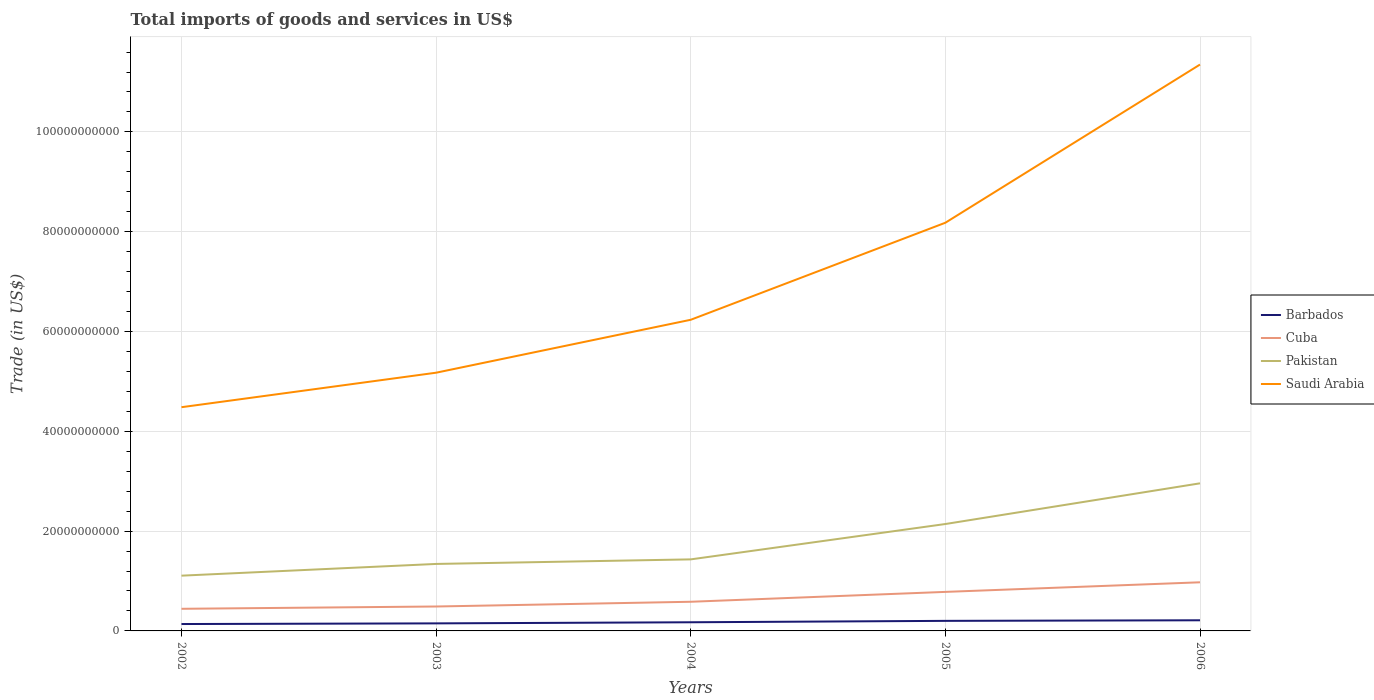How many different coloured lines are there?
Make the answer very short. 4. Is the number of lines equal to the number of legend labels?
Offer a very short reply. Yes. Across all years, what is the maximum total imports of goods and services in Saudi Arabia?
Offer a very short reply. 4.48e+1. What is the total total imports of goods and services in Saudi Arabia in the graph?
Make the answer very short. -1.94e+1. What is the difference between the highest and the second highest total imports of goods and services in Pakistan?
Make the answer very short. 1.85e+1. What is the difference between the highest and the lowest total imports of goods and services in Saudi Arabia?
Keep it short and to the point. 2. Is the total imports of goods and services in Cuba strictly greater than the total imports of goods and services in Barbados over the years?
Make the answer very short. No. How many lines are there?
Provide a succinct answer. 4. Are the values on the major ticks of Y-axis written in scientific E-notation?
Provide a short and direct response. No. Where does the legend appear in the graph?
Keep it short and to the point. Center right. How are the legend labels stacked?
Provide a short and direct response. Vertical. What is the title of the graph?
Ensure brevity in your answer.  Total imports of goods and services in US$. Does "Equatorial Guinea" appear as one of the legend labels in the graph?
Give a very brief answer. No. What is the label or title of the X-axis?
Provide a short and direct response. Years. What is the label or title of the Y-axis?
Keep it short and to the point. Trade (in US$). What is the Trade (in US$) in Barbados in 2002?
Offer a very short reply. 1.38e+09. What is the Trade (in US$) in Cuba in 2002?
Offer a terse response. 4.43e+09. What is the Trade (in US$) in Pakistan in 2002?
Offer a very short reply. 1.11e+1. What is the Trade (in US$) in Saudi Arabia in 2002?
Your answer should be very brief. 4.48e+1. What is the Trade (in US$) in Barbados in 2003?
Offer a terse response. 1.51e+09. What is the Trade (in US$) in Cuba in 2003?
Ensure brevity in your answer.  4.90e+09. What is the Trade (in US$) in Pakistan in 2003?
Provide a succinct answer. 1.34e+1. What is the Trade (in US$) in Saudi Arabia in 2003?
Provide a succinct answer. 5.17e+1. What is the Trade (in US$) of Barbados in 2004?
Make the answer very short. 1.73e+09. What is the Trade (in US$) in Cuba in 2004?
Offer a terse response. 5.84e+09. What is the Trade (in US$) in Pakistan in 2004?
Offer a very short reply. 1.43e+1. What is the Trade (in US$) of Saudi Arabia in 2004?
Your answer should be very brief. 6.24e+1. What is the Trade (in US$) of Barbados in 2005?
Keep it short and to the point. 2.02e+09. What is the Trade (in US$) in Cuba in 2005?
Offer a terse response. 7.82e+09. What is the Trade (in US$) in Pakistan in 2005?
Give a very brief answer. 2.14e+1. What is the Trade (in US$) in Saudi Arabia in 2005?
Offer a terse response. 8.18e+1. What is the Trade (in US$) of Barbados in 2006?
Give a very brief answer. 2.13e+09. What is the Trade (in US$) of Cuba in 2006?
Provide a short and direct response. 9.74e+09. What is the Trade (in US$) in Pakistan in 2006?
Keep it short and to the point. 2.96e+1. What is the Trade (in US$) of Saudi Arabia in 2006?
Provide a short and direct response. 1.13e+11. Across all years, what is the maximum Trade (in US$) of Barbados?
Provide a succinct answer. 2.13e+09. Across all years, what is the maximum Trade (in US$) of Cuba?
Your answer should be very brief. 9.74e+09. Across all years, what is the maximum Trade (in US$) of Pakistan?
Provide a short and direct response. 2.96e+1. Across all years, what is the maximum Trade (in US$) in Saudi Arabia?
Offer a terse response. 1.13e+11. Across all years, what is the minimum Trade (in US$) of Barbados?
Your answer should be compact. 1.38e+09. Across all years, what is the minimum Trade (in US$) in Cuba?
Provide a succinct answer. 4.43e+09. Across all years, what is the minimum Trade (in US$) of Pakistan?
Offer a terse response. 1.11e+1. Across all years, what is the minimum Trade (in US$) in Saudi Arabia?
Ensure brevity in your answer.  4.48e+1. What is the total Trade (in US$) of Barbados in the graph?
Keep it short and to the point. 8.78e+09. What is the total Trade (in US$) in Cuba in the graph?
Make the answer very short. 3.27e+1. What is the total Trade (in US$) in Pakistan in the graph?
Offer a very short reply. 8.98e+1. What is the total Trade (in US$) of Saudi Arabia in the graph?
Ensure brevity in your answer.  3.54e+11. What is the difference between the Trade (in US$) in Barbados in 2002 and that in 2003?
Your response must be concise. -1.31e+08. What is the difference between the Trade (in US$) of Cuba in 2002 and that in 2003?
Ensure brevity in your answer.  -4.60e+08. What is the difference between the Trade (in US$) in Pakistan in 2002 and that in 2003?
Your response must be concise. -2.35e+09. What is the difference between the Trade (in US$) in Saudi Arabia in 2002 and that in 2003?
Your answer should be very brief. -6.91e+09. What is the difference between the Trade (in US$) of Barbados in 2002 and that in 2004?
Ensure brevity in your answer.  -3.52e+08. What is the difference between the Trade (in US$) in Cuba in 2002 and that in 2004?
Make the answer very short. -1.41e+09. What is the difference between the Trade (in US$) of Pakistan in 2002 and that in 2004?
Provide a succinct answer. -3.26e+09. What is the difference between the Trade (in US$) of Saudi Arabia in 2002 and that in 2004?
Give a very brief answer. -1.75e+1. What is the difference between the Trade (in US$) of Barbados in 2002 and that in 2005?
Keep it short and to the point. -6.35e+08. What is the difference between the Trade (in US$) of Cuba in 2002 and that in 2005?
Give a very brief answer. -3.39e+09. What is the difference between the Trade (in US$) in Pakistan in 2002 and that in 2005?
Offer a very short reply. -1.03e+1. What is the difference between the Trade (in US$) of Saudi Arabia in 2002 and that in 2005?
Offer a terse response. -3.70e+1. What is the difference between the Trade (in US$) in Barbados in 2002 and that in 2006?
Offer a very short reply. -7.50e+08. What is the difference between the Trade (in US$) in Cuba in 2002 and that in 2006?
Provide a short and direct response. -5.31e+09. What is the difference between the Trade (in US$) in Pakistan in 2002 and that in 2006?
Provide a succinct answer. -1.85e+1. What is the difference between the Trade (in US$) of Saudi Arabia in 2002 and that in 2006?
Your answer should be very brief. -6.87e+1. What is the difference between the Trade (in US$) of Barbados in 2003 and that in 2004?
Provide a succinct answer. -2.22e+08. What is the difference between the Trade (in US$) of Cuba in 2003 and that in 2004?
Keep it short and to the point. -9.46e+08. What is the difference between the Trade (in US$) of Pakistan in 2003 and that in 2004?
Keep it short and to the point. -9.14e+08. What is the difference between the Trade (in US$) of Saudi Arabia in 2003 and that in 2004?
Your response must be concise. -1.06e+1. What is the difference between the Trade (in US$) in Barbados in 2003 and that in 2005?
Your answer should be very brief. -5.04e+08. What is the difference between the Trade (in US$) in Cuba in 2003 and that in 2005?
Provide a succinct answer. -2.93e+09. What is the difference between the Trade (in US$) in Pakistan in 2003 and that in 2005?
Make the answer very short. -8.00e+09. What is the difference between the Trade (in US$) of Saudi Arabia in 2003 and that in 2005?
Give a very brief answer. -3.01e+1. What is the difference between the Trade (in US$) in Barbados in 2003 and that in 2006?
Provide a succinct answer. -6.19e+08. What is the difference between the Trade (in US$) in Cuba in 2003 and that in 2006?
Ensure brevity in your answer.  -4.85e+09. What is the difference between the Trade (in US$) in Pakistan in 2003 and that in 2006?
Give a very brief answer. -1.62e+1. What is the difference between the Trade (in US$) in Saudi Arabia in 2003 and that in 2006?
Make the answer very short. -6.18e+1. What is the difference between the Trade (in US$) in Barbados in 2004 and that in 2005?
Offer a very short reply. -2.82e+08. What is the difference between the Trade (in US$) in Cuba in 2004 and that in 2005?
Your answer should be very brief. -1.98e+09. What is the difference between the Trade (in US$) in Pakistan in 2004 and that in 2005?
Offer a terse response. -7.09e+09. What is the difference between the Trade (in US$) in Saudi Arabia in 2004 and that in 2005?
Offer a terse response. -1.94e+1. What is the difference between the Trade (in US$) of Barbados in 2004 and that in 2006?
Your answer should be very brief. -3.98e+08. What is the difference between the Trade (in US$) of Cuba in 2004 and that in 2006?
Keep it short and to the point. -3.90e+09. What is the difference between the Trade (in US$) of Pakistan in 2004 and that in 2006?
Keep it short and to the point. -1.52e+1. What is the difference between the Trade (in US$) of Saudi Arabia in 2004 and that in 2006?
Provide a succinct answer. -5.11e+1. What is the difference between the Trade (in US$) of Barbados in 2005 and that in 2006?
Your response must be concise. -1.15e+08. What is the difference between the Trade (in US$) of Cuba in 2005 and that in 2006?
Ensure brevity in your answer.  -1.92e+09. What is the difference between the Trade (in US$) of Pakistan in 2005 and that in 2006?
Keep it short and to the point. -8.15e+09. What is the difference between the Trade (in US$) in Saudi Arabia in 2005 and that in 2006?
Provide a succinct answer. -3.17e+1. What is the difference between the Trade (in US$) in Barbados in 2002 and the Trade (in US$) in Cuba in 2003?
Provide a succinct answer. -3.51e+09. What is the difference between the Trade (in US$) of Barbados in 2002 and the Trade (in US$) of Pakistan in 2003?
Provide a short and direct response. -1.20e+1. What is the difference between the Trade (in US$) in Barbados in 2002 and the Trade (in US$) in Saudi Arabia in 2003?
Ensure brevity in your answer.  -5.04e+1. What is the difference between the Trade (in US$) in Cuba in 2002 and the Trade (in US$) in Pakistan in 2003?
Your answer should be compact. -8.99e+09. What is the difference between the Trade (in US$) in Cuba in 2002 and the Trade (in US$) in Saudi Arabia in 2003?
Ensure brevity in your answer.  -4.73e+1. What is the difference between the Trade (in US$) in Pakistan in 2002 and the Trade (in US$) in Saudi Arabia in 2003?
Keep it short and to the point. -4.07e+1. What is the difference between the Trade (in US$) in Barbados in 2002 and the Trade (in US$) in Cuba in 2004?
Offer a terse response. -4.46e+09. What is the difference between the Trade (in US$) of Barbados in 2002 and the Trade (in US$) of Pakistan in 2004?
Provide a short and direct response. -1.30e+1. What is the difference between the Trade (in US$) of Barbados in 2002 and the Trade (in US$) of Saudi Arabia in 2004?
Your answer should be compact. -6.10e+1. What is the difference between the Trade (in US$) in Cuba in 2002 and the Trade (in US$) in Pakistan in 2004?
Offer a very short reply. -9.90e+09. What is the difference between the Trade (in US$) of Cuba in 2002 and the Trade (in US$) of Saudi Arabia in 2004?
Ensure brevity in your answer.  -5.79e+1. What is the difference between the Trade (in US$) of Pakistan in 2002 and the Trade (in US$) of Saudi Arabia in 2004?
Your answer should be very brief. -5.13e+1. What is the difference between the Trade (in US$) in Barbados in 2002 and the Trade (in US$) in Cuba in 2005?
Offer a very short reply. -6.44e+09. What is the difference between the Trade (in US$) of Barbados in 2002 and the Trade (in US$) of Pakistan in 2005?
Your response must be concise. -2.00e+1. What is the difference between the Trade (in US$) in Barbados in 2002 and the Trade (in US$) in Saudi Arabia in 2005?
Keep it short and to the point. -8.04e+1. What is the difference between the Trade (in US$) of Cuba in 2002 and the Trade (in US$) of Pakistan in 2005?
Your response must be concise. -1.70e+1. What is the difference between the Trade (in US$) in Cuba in 2002 and the Trade (in US$) in Saudi Arabia in 2005?
Provide a short and direct response. -7.74e+1. What is the difference between the Trade (in US$) in Pakistan in 2002 and the Trade (in US$) in Saudi Arabia in 2005?
Give a very brief answer. -7.07e+1. What is the difference between the Trade (in US$) in Barbados in 2002 and the Trade (in US$) in Cuba in 2006?
Provide a short and direct response. -8.36e+09. What is the difference between the Trade (in US$) in Barbados in 2002 and the Trade (in US$) in Pakistan in 2006?
Your answer should be compact. -2.82e+1. What is the difference between the Trade (in US$) in Barbados in 2002 and the Trade (in US$) in Saudi Arabia in 2006?
Provide a short and direct response. -1.12e+11. What is the difference between the Trade (in US$) in Cuba in 2002 and the Trade (in US$) in Pakistan in 2006?
Provide a short and direct response. -2.51e+1. What is the difference between the Trade (in US$) of Cuba in 2002 and the Trade (in US$) of Saudi Arabia in 2006?
Offer a very short reply. -1.09e+11. What is the difference between the Trade (in US$) of Pakistan in 2002 and the Trade (in US$) of Saudi Arabia in 2006?
Provide a short and direct response. -1.02e+11. What is the difference between the Trade (in US$) of Barbados in 2003 and the Trade (in US$) of Cuba in 2004?
Make the answer very short. -4.33e+09. What is the difference between the Trade (in US$) of Barbados in 2003 and the Trade (in US$) of Pakistan in 2004?
Offer a terse response. -1.28e+1. What is the difference between the Trade (in US$) in Barbados in 2003 and the Trade (in US$) in Saudi Arabia in 2004?
Your answer should be very brief. -6.08e+1. What is the difference between the Trade (in US$) in Cuba in 2003 and the Trade (in US$) in Pakistan in 2004?
Provide a succinct answer. -9.44e+09. What is the difference between the Trade (in US$) in Cuba in 2003 and the Trade (in US$) in Saudi Arabia in 2004?
Make the answer very short. -5.75e+1. What is the difference between the Trade (in US$) of Pakistan in 2003 and the Trade (in US$) of Saudi Arabia in 2004?
Your response must be concise. -4.89e+1. What is the difference between the Trade (in US$) in Barbados in 2003 and the Trade (in US$) in Cuba in 2005?
Ensure brevity in your answer.  -6.31e+09. What is the difference between the Trade (in US$) in Barbados in 2003 and the Trade (in US$) in Pakistan in 2005?
Your answer should be compact. -1.99e+1. What is the difference between the Trade (in US$) of Barbados in 2003 and the Trade (in US$) of Saudi Arabia in 2005?
Offer a very short reply. -8.03e+1. What is the difference between the Trade (in US$) of Cuba in 2003 and the Trade (in US$) of Pakistan in 2005?
Give a very brief answer. -1.65e+1. What is the difference between the Trade (in US$) in Cuba in 2003 and the Trade (in US$) in Saudi Arabia in 2005?
Ensure brevity in your answer.  -7.69e+1. What is the difference between the Trade (in US$) in Pakistan in 2003 and the Trade (in US$) in Saudi Arabia in 2005?
Make the answer very short. -6.84e+1. What is the difference between the Trade (in US$) in Barbados in 2003 and the Trade (in US$) in Cuba in 2006?
Your response must be concise. -8.23e+09. What is the difference between the Trade (in US$) of Barbados in 2003 and the Trade (in US$) of Pakistan in 2006?
Provide a short and direct response. -2.81e+1. What is the difference between the Trade (in US$) in Barbados in 2003 and the Trade (in US$) in Saudi Arabia in 2006?
Your response must be concise. -1.12e+11. What is the difference between the Trade (in US$) in Cuba in 2003 and the Trade (in US$) in Pakistan in 2006?
Keep it short and to the point. -2.47e+1. What is the difference between the Trade (in US$) of Cuba in 2003 and the Trade (in US$) of Saudi Arabia in 2006?
Your answer should be very brief. -1.09e+11. What is the difference between the Trade (in US$) of Pakistan in 2003 and the Trade (in US$) of Saudi Arabia in 2006?
Make the answer very short. -1.00e+11. What is the difference between the Trade (in US$) of Barbados in 2004 and the Trade (in US$) of Cuba in 2005?
Ensure brevity in your answer.  -6.09e+09. What is the difference between the Trade (in US$) in Barbados in 2004 and the Trade (in US$) in Pakistan in 2005?
Give a very brief answer. -1.97e+1. What is the difference between the Trade (in US$) in Barbados in 2004 and the Trade (in US$) in Saudi Arabia in 2005?
Make the answer very short. -8.01e+1. What is the difference between the Trade (in US$) of Cuba in 2004 and the Trade (in US$) of Pakistan in 2005?
Ensure brevity in your answer.  -1.56e+1. What is the difference between the Trade (in US$) of Cuba in 2004 and the Trade (in US$) of Saudi Arabia in 2005?
Provide a succinct answer. -7.60e+1. What is the difference between the Trade (in US$) of Pakistan in 2004 and the Trade (in US$) of Saudi Arabia in 2005?
Offer a terse response. -6.75e+1. What is the difference between the Trade (in US$) in Barbados in 2004 and the Trade (in US$) in Cuba in 2006?
Your answer should be very brief. -8.01e+09. What is the difference between the Trade (in US$) of Barbados in 2004 and the Trade (in US$) of Pakistan in 2006?
Your response must be concise. -2.78e+1. What is the difference between the Trade (in US$) in Barbados in 2004 and the Trade (in US$) in Saudi Arabia in 2006?
Your answer should be compact. -1.12e+11. What is the difference between the Trade (in US$) of Cuba in 2004 and the Trade (in US$) of Pakistan in 2006?
Keep it short and to the point. -2.37e+1. What is the difference between the Trade (in US$) of Cuba in 2004 and the Trade (in US$) of Saudi Arabia in 2006?
Make the answer very short. -1.08e+11. What is the difference between the Trade (in US$) in Pakistan in 2004 and the Trade (in US$) in Saudi Arabia in 2006?
Your response must be concise. -9.92e+1. What is the difference between the Trade (in US$) of Barbados in 2005 and the Trade (in US$) of Cuba in 2006?
Ensure brevity in your answer.  -7.73e+09. What is the difference between the Trade (in US$) in Barbados in 2005 and the Trade (in US$) in Pakistan in 2006?
Give a very brief answer. -2.76e+1. What is the difference between the Trade (in US$) of Barbados in 2005 and the Trade (in US$) of Saudi Arabia in 2006?
Your answer should be very brief. -1.11e+11. What is the difference between the Trade (in US$) in Cuba in 2005 and the Trade (in US$) in Pakistan in 2006?
Your response must be concise. -2.18e+1. What is the difference between the Trade (in US$) in Cuba in 2005 and the Trade (in US$) in Saudi Arabia in 2006?
Offer a terse response. -1.06e+11. What is the difference between the Trade (in US$) in Pakistan in 2005 and the Trade (in US$) in Saudi Arabia in 2006?
Provide a short and direct response. -9.21e+1. What is the average Trade (in US$) in Barbados per year?
Offer a very short reply. 1.76e+09. What is the average Trade (in US$) in Cuba per year?
Your answer should be very brief. 6.55e+09. What is the average Trade (in US$) of Pakistan per year?
Offer a very short reply. 1.80e+1. What is the average Trade (in US$) in Saudi Arabia per year?
Give a very brief answer. 7.08e+1. In the year 2002, what is the difference between the Trade (in US$) in Barbados and Trade (in US$) in Cuba?
Offer a terse response. -3.05e+09. In the year 2002, what is the difference between the Trade (in US$) in Barbados and Trade (in US$) in Pakistan?
Your answer should be compact. -9.69e+09. In the year 2002, what is the difference between the Trade (in US$) in Barbados and Trade (in US$) in Saudi Arabia?
Your answer should be compact. -4.34e+1. In the year 2002, what is the difference between the Trade (in US$) of Cuba and Trade (in US$) of Pakistan?
Your answer should be compact. -6.64e+09. In the year 2002, what is the difference between the Trade (in US$) of Cuba and Trade (in US$) of Saudi Arabia?
Give a very brief answer. -4.04e+1. In the year 2002, what is the difference between the Trade (in US$) in Pakistan and Trade (in US$) in Saudi Arabia?
Provide a short and direct response. -3.38e+1. In the year 2003, what is the difference between the Trade (in US$) in Barbados and Trade (in US$) in Cuba?
Your answer should be very brief. -3.38e+09. In the year 2003, what is the difference between the Trade (in US$) of Barbados and Trade (in US$) of Pakistan?
Your answer should be very brief. -1.19e+1. In the year 2003, what is the difference between the Trade (in US$) in Barbados and Trade (in US$) in Saudi Arabia?
Offer a very short reply. -5.02e+1. In the year 2003, what is the difference between the Trade (in US$) of Cuba and Trade (in US$) of Pakistan?
Keep it short and to the point. -8.53e+09. In the year 2003, what is the difference between the Trade (in US$) of Cuba and Trade (in US$) of Saudi Arabia?
Provide a short and direct response. -4.68e+1. In the year 2003, what is the difference between the Trade (in US$) of Pakistan and Trade (in US$) of Saudi Arabia?
Your response must be concise. -3.83e+1. In the year 2004, what is the difference between the Trade (in US$) in Barbados and Trade (in US$) in Cuba?
Keep it short and to the point. -4.11e+09. In the year 2004, what is the difference between the Trade (in US$) of Barbados and Trade (in US$) of Pakistan?
Offer a terse response. -1.26e+1. In the year 2004, what is the difference between the Trade (in US$) of Barbados and Trade (in US$) of Saudi Arabia?
Your response must be concise. -6.06e+1. In the year 2004, what is the difference between the Trade (in US$) of Cuba and Trade (in US$) of Pakistan?
Your answer should be compact. -8.50e+09. In the year 2004, what is the difference between the Trade (in US$) in Cuba and Trade (in US$) in Saudi Arabia?
Ensure brevity in your answer.  -5.65e+1. In the year 2004, what is the difference between the Trade (in US$) of Pakistan and Trade (in US$) of Saudi Arabia?
Make the answer very short. -4.80e+1. In the year 2005, what is the difference between the Trade (in US$) of Barbados and Trade (in US$) of Cuba?
Your answer should be compact. -5.81e+09. In the year 2005, what is the difference between the Trade (in US$) of Barbados and Trade (in US$) of Pakistan?
Ensure brevity in your answer.  -1.94e+1. In the year 2005, what is the difference between the Trade (in US$) of Barbados and Trade (in US$) of Saudi Arabia?
Provide a succinct answer. -7.98e+1. In the year 2005, what is the difference between the Trade (in US$) in Cuba and Trade (in US$) in Pakistan?
Ensure brevity in your answer.  -1.36e+1. In the year 2005, what is the difference between the Trade (in US$) in Cuba and Trade (in US$) in Saudi Arabia?
Provide a short and direct response. -7.40e+1. In the year 2005, what is the difference between the Trade (in US$) of Pakistan and Trade (in US$) of Saudi Arabia?
Your answer should be very brief. -6.04e+1. In the year 2006, what is the difference between the Trade (in US$) in Barbados and Trade (in US$) in Cuba?
Your answer should be compact. -7.61e+09. In the year 2006, what is the difference between the Trade (in US$) of Barbados and Trade (in US$) of Pakistan?
Your response must be concise. -2.74e+1. In the year 2006, what is the difference between the Trade (in US$) in Barbados and Trade (in US$) in Saudi Arabia?
Provide a succinct answer. -1.11e+11. In the year 2006, what is the difference between the Trade (in US$) in Cuba and Trade (in US$) in Pakistan?
Provide a succinct answer. -1.98e+1. In the year 2006, what is the difference between the Trade (in US$) of Cuba and Trade (in US$) of Saudi Arabia?
Offer a very short reply. -1.04e+11. In the year 2006, what is the difference between the Trade (in US$) in Pakistan and Trade (in US$) in Saudi Arabia?
Your response must be concise. -8.39e+1. What is the ratio of the Trade (in US$) in Barbados in 2002 to that in 2003?
Keep it short and to the point. 0.91. What is the ratio of the Trade (in US$) of Cuba in 2002 to that in 2003?
Ensure brevity in your answer.  0.91. What is the ratio of the Trade (in US$) of Pakistan in 2002 to that in 2003?
Make the answer very short. 0.82. What is the ratio of the Trade (in US$) of Saudi Arabia in 2002 to that in 2003?
Offer a terse response. 0.87. What is the ratio of the Trade (in US$) of Barbados in 2002 to that in 2004?
Offer a terse response. 0.8. What is the ratio of the Trade (in US$) of Cuba in 2002 to that in 2004?
Ensure brevity in your answer.  0.76. What is the ratio of the Trade (in US$) of Pakistan in 2002 to that in 2004?
Give a very brief answer. 0.77. What is the ratio of the Trade (in US$) of Saudi Arabia in 2002 to that in 2004?
Make the answer very short. 0.72. What is the ratio of the Trade (in US$) of Barbados in 2002 to that in 2005?
Your response must be concise. 0.69. What is the ratio of the Trade (in US$) of Cuba in 2002 to that in 2005?
Your answer should be very brief. 0.57. What is the ratio of the Trade (in US$) in Pakistan in 2002 to that in 2005?
Provide a succinct answer. 0.52. What is the ratio of the Trade (in US$) in Saudi Arabia in 2002 to that in 2005?
Offer a very short reply. 0.55. What is the ratio of the Trade (in US$) in Barbados in 2002 to that in 2006?
Provide a short and direct response. 0.65. What is the ratio of the Trade (in US$) in Cuba in 2002 to that in 2006?
Ensure brevity in your answer.  0.46. What is the ratio of the Trade (in US$) of Pakistan in 2002 to that in 2006?
Offer a very short reply. 0.37. What is the ratio of the Trade (in US$) in Saudi Arabia in 2002 to that in 2006?
Ensure brevity in your answer.  0.4. What is the ratio of the Trade (in US$) of Barbados in 2003 to that in 2004?
Keep it short and to the point. 0.87. What is the ratio of the Trade (in US$) in Cuba in 2003 to that in 2004?
Offer a terse response. 0.84. What is the ratio of the Trade (in US$) of Pakistan in 2003 to that in 2004?
Give a very brief answer. 0.94. What is the ratio of the Trade (in US$) of Saudi Arabia in 2003 to that in 2004?
Offer a very short reply. 0.83. What is the ratio of the Trade (in US$) of Barbados in 2003 to that in 2005?
Ensure brevity in your answer.  0.75. What is the ratio of the Trade (in US$) of Cuba in 2003 to that in 2005?
Offer a very short reply. 0.63. What is the ratio of the Trade (in US$) of Pakistan in 2003 to that in 2005?
Your answer should be compact. 0.63. What is the ratio of the Trade (in US$) in Saudi Arabia in 2003 to that in 2005?
Give a very brief answer. 0.63. What is the ratio of the Trade (in US$) of Barbados in 2003 to that in 2006?
Offer a terse response. 0.71. What is the ratio of the Trade (in US$) of Cuba in 2003 to that in 2006?
Provide a succinct answer. 0.5. What is the ratio of the Trade (in US$) in Pakistan in 2003 to that in 2006?
Your response must be concise. 0.45. What is the ratio of the Trade (in US$) of Saudi Arabia in 2003 to that in 2006?
Provide a succinct answer. 0.46. What is the ratio of the Trade (in US$) in Barbados in 2004 to that in 2005?
Your answer should be very brief. 0.86. What is the ratio of the Trade (in US$) in Cuba in 2004 to that in 2005?
Ensure brevity in your answer.  0.75. What is the ratio of the Trade (in US$) in Pakistan in 2004 to that in 2005?
Ensure brevity in your answer.  0.67. What is the ratio of the Trade (in US$) of Saudi Arabia in 2004 to that in 2005?
Your answer should be very brief. 0.76. What is the ratio of the Trade (in US$) of Barbados in 2004 to that in 2006?
Offer a very short reply. 0.81. What is the ratio of the Trade (in US$) in Cuba in 2004 to that in 2006?
Your answer should be compact. 0.6. What is the ratio of the Trade (in US$) in Pakistan in 2004 to that in 2006?
Keep it short and to the point. 0.48. What is the ratio of the Trade (in US$) of Saudi Arabia in 2004 to that in 2006?
Offer a very short reply. 0.55. What is the ratio of the Trade (in US$) of Barbados in 2005 to that in 2006?
Provide a short and direct response. 0.95. What is the ratio of the Trade (in US$) in Cuba in 2005 to that in 2006?
Your answer should be very brief. 0.8. What is the ratio of the Trade (in US$) of Pakistan in 2005 to that in 2006?
Offer a terse response. 0.72. What is the ratio of the Trade (in US$) of Saudi Arabia in 2005 to that in 2006?
Make the answer very short. 0.72. What is the difference between the highest and the second highest Trade (in US$) in Barbados?
Provide a short and direct response. 1.15e+08. What is the difference between the highest and the second highest Trade (in US$) in Cuba?
Your answer should be very brief. 1.92e+09. What is the difference between the highest and the second highest Trade (in US$) in Pakistan?
Offer a terse response. 8.15e+09. What is the difference between the highest and the second highest Trade (in US$) in Saudi Arabia?
Give a very brief answer. 3.17e+1. What is the difference between the highest and the lowest Trade (in US$) in Barbados?
Provide a short and direct response. 7.50e+08. What is the difference between the highest and the lowest Trade (in US$) in Cuba?
Give a very brief answer. 5.31e+09. What is the difference between the highest and the lowest Trade (in US$) in Pakistan?
Offer a terse response. 1.85e+1. What is the difference between the highest and the lowest Trade (in US$) in Saudi Arabia?
Keep it short and to the point. 6.87e+1. 